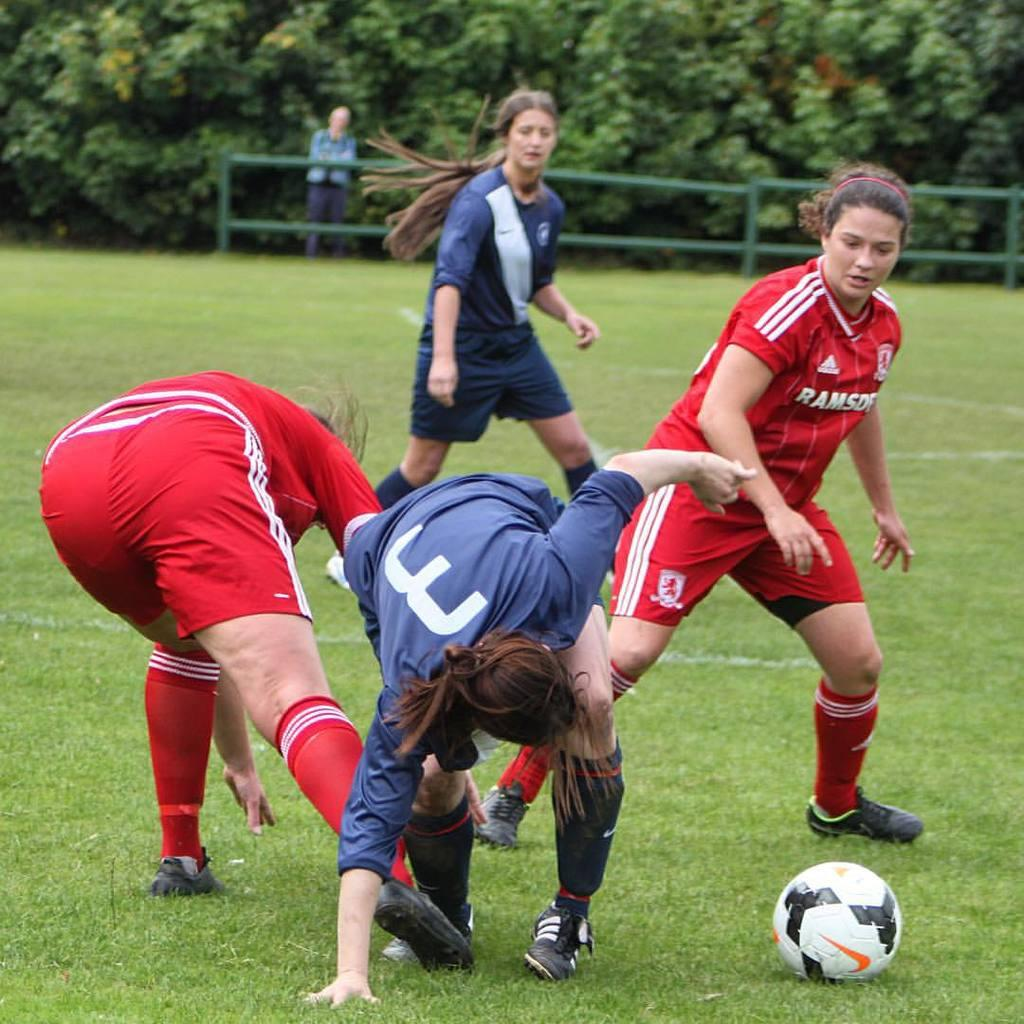<image>
Describe the image concisely. Players playing soccer with one wearing a red jersey that says RAMSO. 